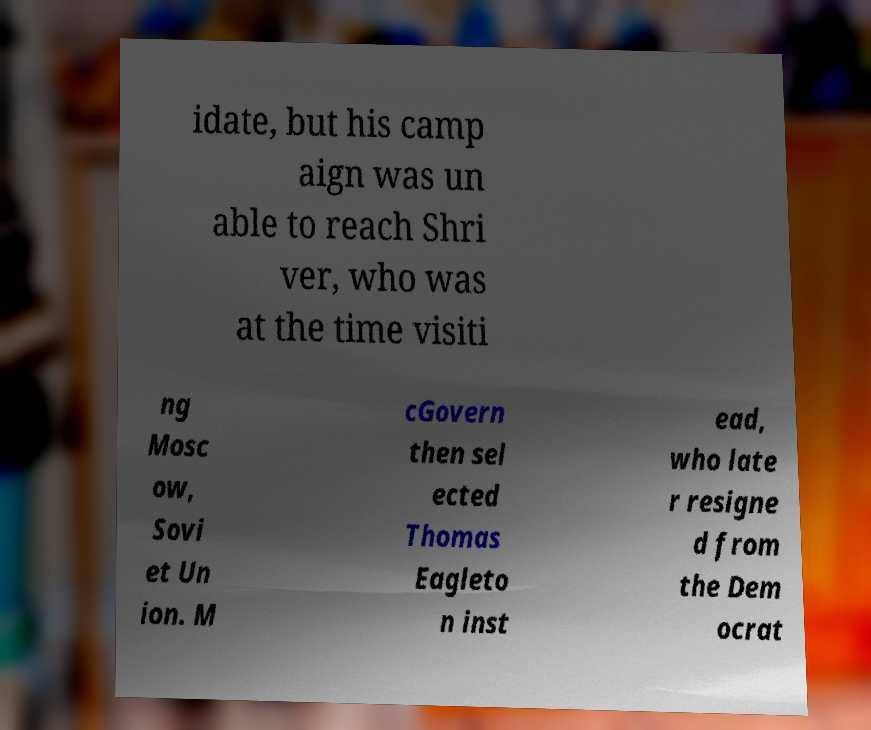I need the written content from this picture converted into text. Can you do that? idate, but his camp aign was un able to reach Shri ver, who was at the time visiti ng Mosc ow, Sovi et Un ion. M cGovern then sel ected Thomas Eagleto n inst ead, who late r resigne d from the Dem ocrat 